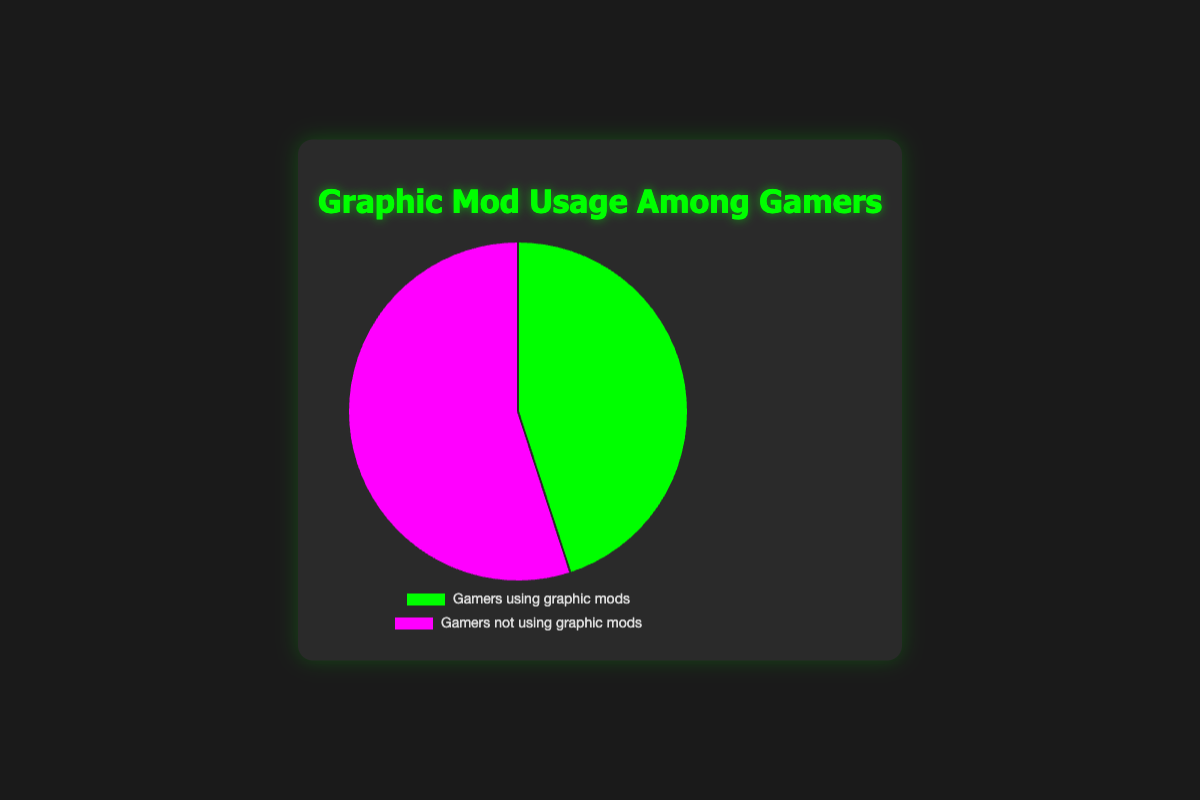How many percentage points is the difference between gamers who use graphic mods and those who don't? The pie chart shows that 45% of gamers use graphic mods and 55% don't. The difference is calculated by subtracting 45 from 55, which equals 10 percentage points.
Answer: 10 Which group of gamers is larger, those who use graphic mods or those who don't? The pie chart shows that 55% of gamers don't use graphic mods while only 45% do. Since 55% is greater than 45%, the group of gamers who don't use graphic mods is larger.
Answer: Gamers who don't use graphic mods What is the total percentage represented by gamers using graphic mods and those not using them? The pie chart divides gamers into two groups, 45% using graphic mods and 55% not using them. Adding these percentages (45 + 55) yields 100%.
Answer: 100% What color represents gamers who use graphic mods in the pie chart? The pie chart uses distinct colors for clarity. Gamers who use graphic mods are represented by the green color in the chart.
Answer: Green How does the percentage of gamers who don't use graphic mods compare to those who do? To compare, the chart shows 55% of gamers don't use graphic mods, while 45% do. Since 55% is greater than 45%, a higher percentage of gamers don't use mods.
Answer: Higher Which category of gamers constitutes the minority in the chart? According to the chart, 45% of gamers use graphic mods, while 55% do not. Because 45% is less than 55%, the minority group is gamers using graphic mods.
Answer: Gamers using graphic mods Is there a category that represents more than half of the gamers? If so, which one? The pie chart shows 55% of gamers don't use graphic mods. Since 55% is more than half (50%), the category that represents more than half is gamers who don't use graphic mods.
Answer: Gamers who don't use graphic mods 